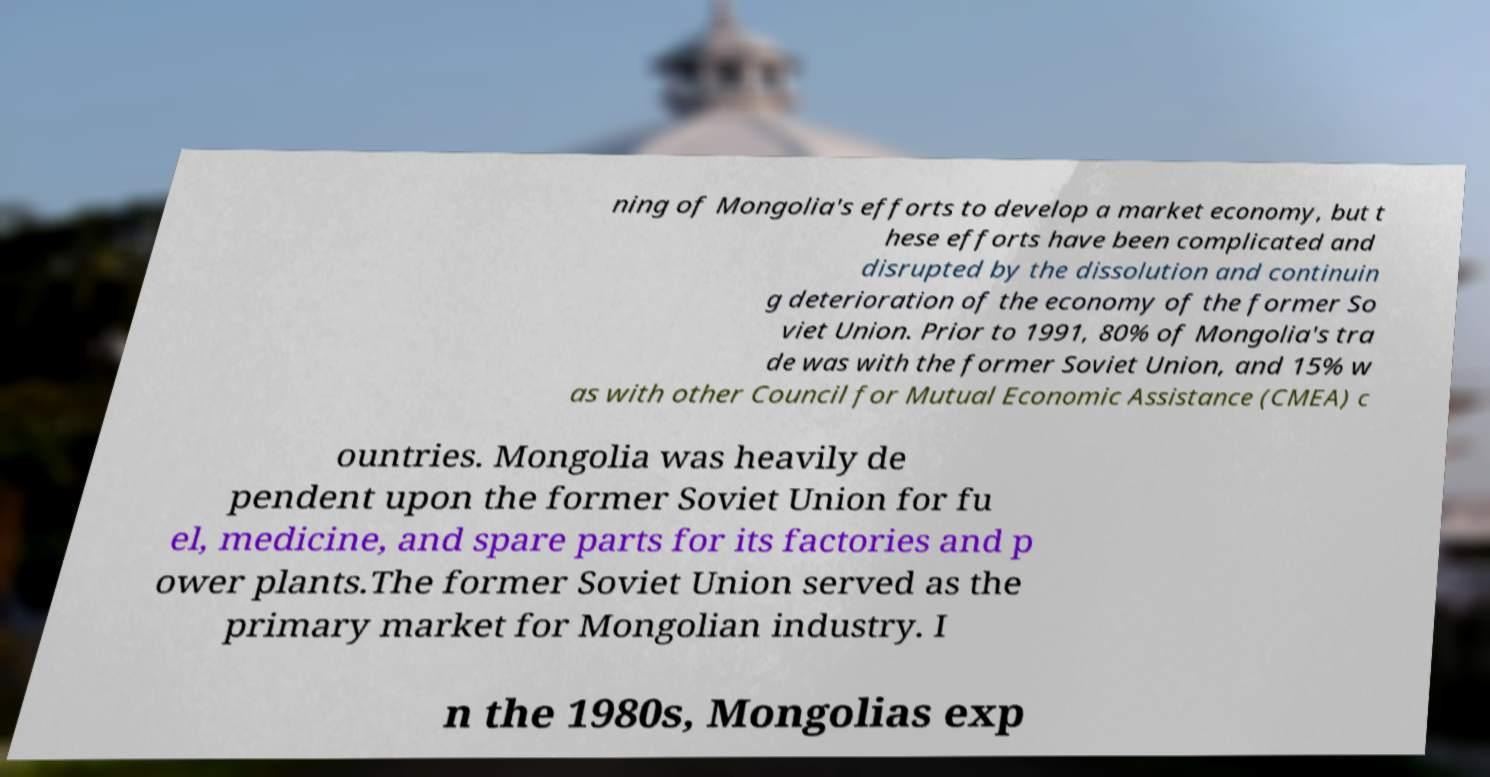Could you extract and type out the text from this image? ning of Mongolia's efforts to develop a market economy, but t hese efforts have been complicated and disrupted by the dissolution and continuin g deterioration of the economy of the former So viet Union. Prior to 1991, 80% of Mongolia's tra de was with the former Soviet Union, and 15% w as with other Council for Mutual Economic Assistance (CMEA) c ountries. Mongolia was heavily de pendent upon the former Soviet Union for fu el, medicine, and spare parts for its factories and p ower plants.The former Soviet Union served as the primary market for Mongolian industry. I n the 1980s, Mongolias exp 